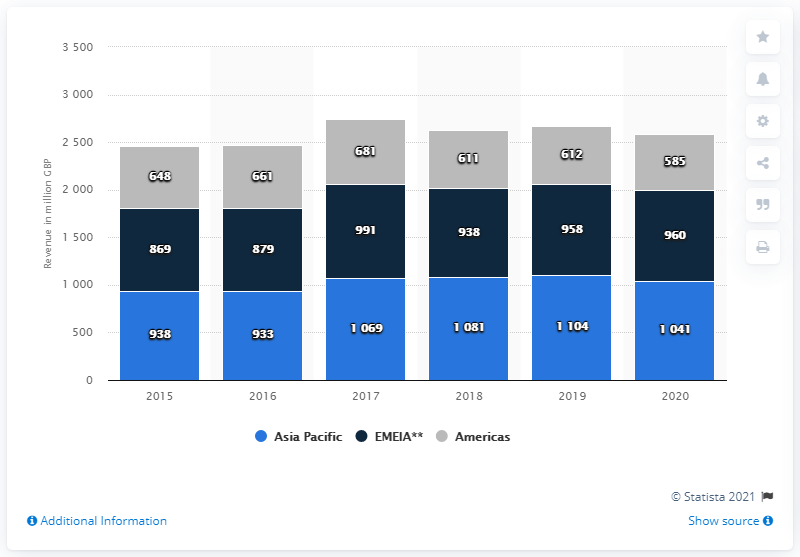Highlight a few significant elements in this photo. The graph shows 6 years. Burberry generated a total global revenue of 2630 million in 2018. In 2020, the global revenue of Burberry's North American channel was approximately 585 million dollars. 